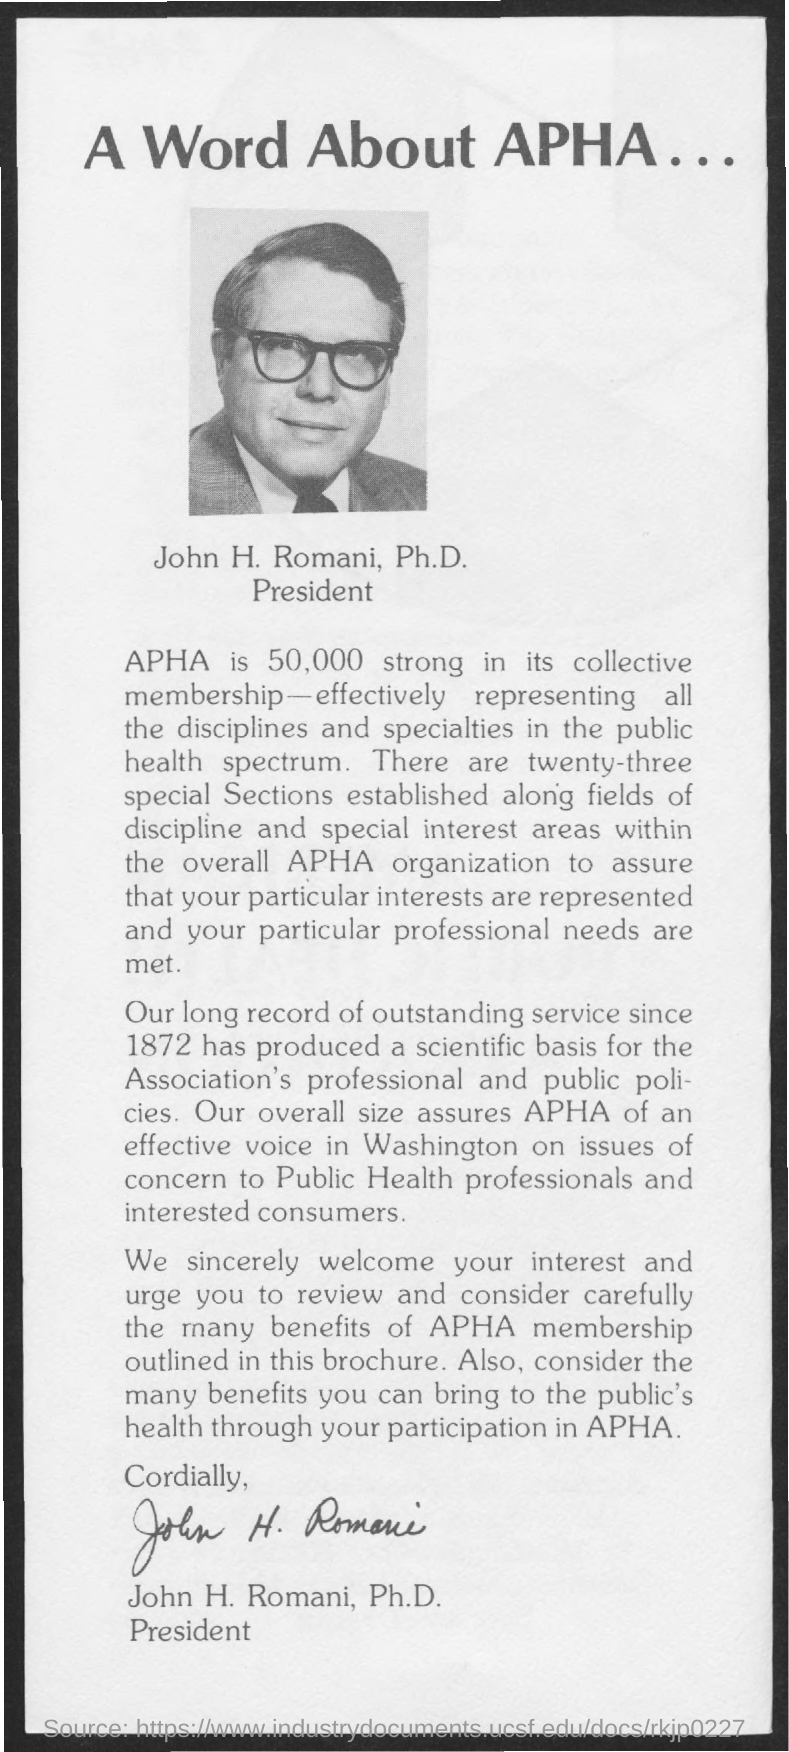What is the title of the document?
Ensure brevity in your answer.  A word about apha... What is the designation of John H. Romani?
Make the answer very short. President. 